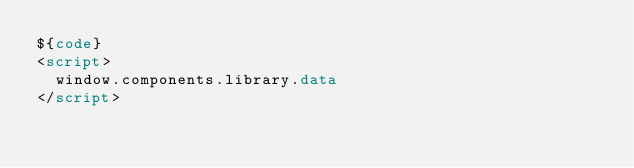<code> <loc_0><loc_0><loc_500><loc_500><_HTML_>${code}
<script>
	window.components.library.data
</script></code> 